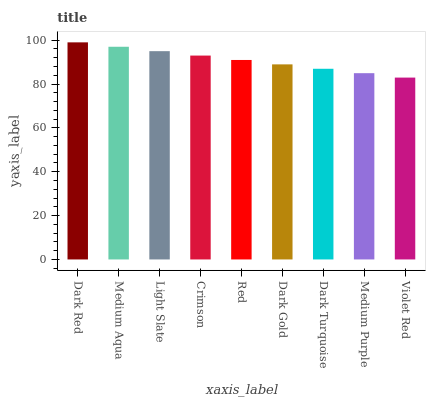Is Violet Red the minimum?
Answer yes or no. Yes. Is Dark Red the maximum?
Answer yes or no. Yes. Is Medium Aqua the minimum?
Answer yes or no. No. Is Medium Aqua the maximum?
Answer yes or no. No. Is Dark Red greater than Medium Aqua?
Answer yes or no. Yes. Is Medium Aqua less than Dark Red?
Answer yes or no. Yes. Is Medium Aqua greater than Dark Red?
Answer yes or no. No. Is Dark Red less than Medium Aqua?
Answer yes or no. No. Is Red the high median?
Answer yes or no. Yes. Is Red the low median?
Answer yes or no. Yes. Is Dark Turquoise the high median?
Answer yes or no. No. Is Crimson the low median?
Answer yes or no. No. 